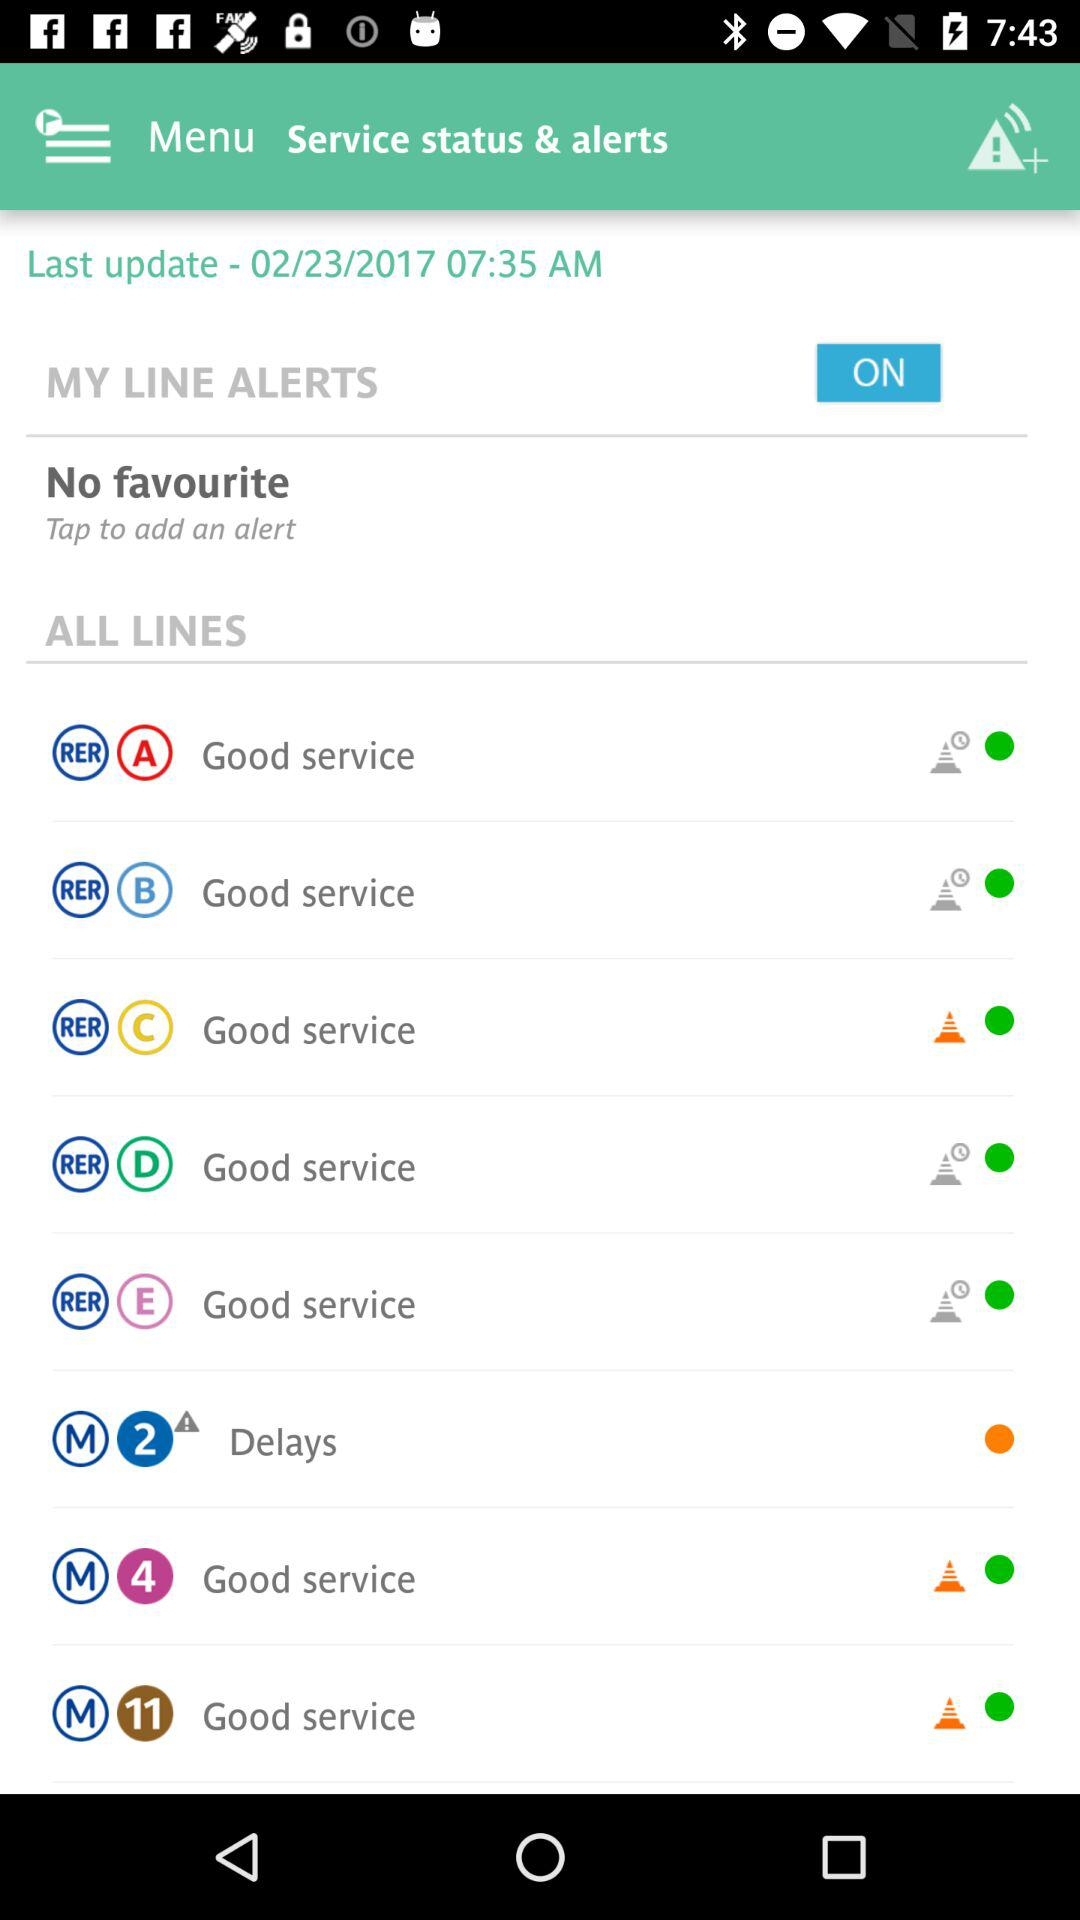What is the date of the last update? The date is February 23, 2017. 